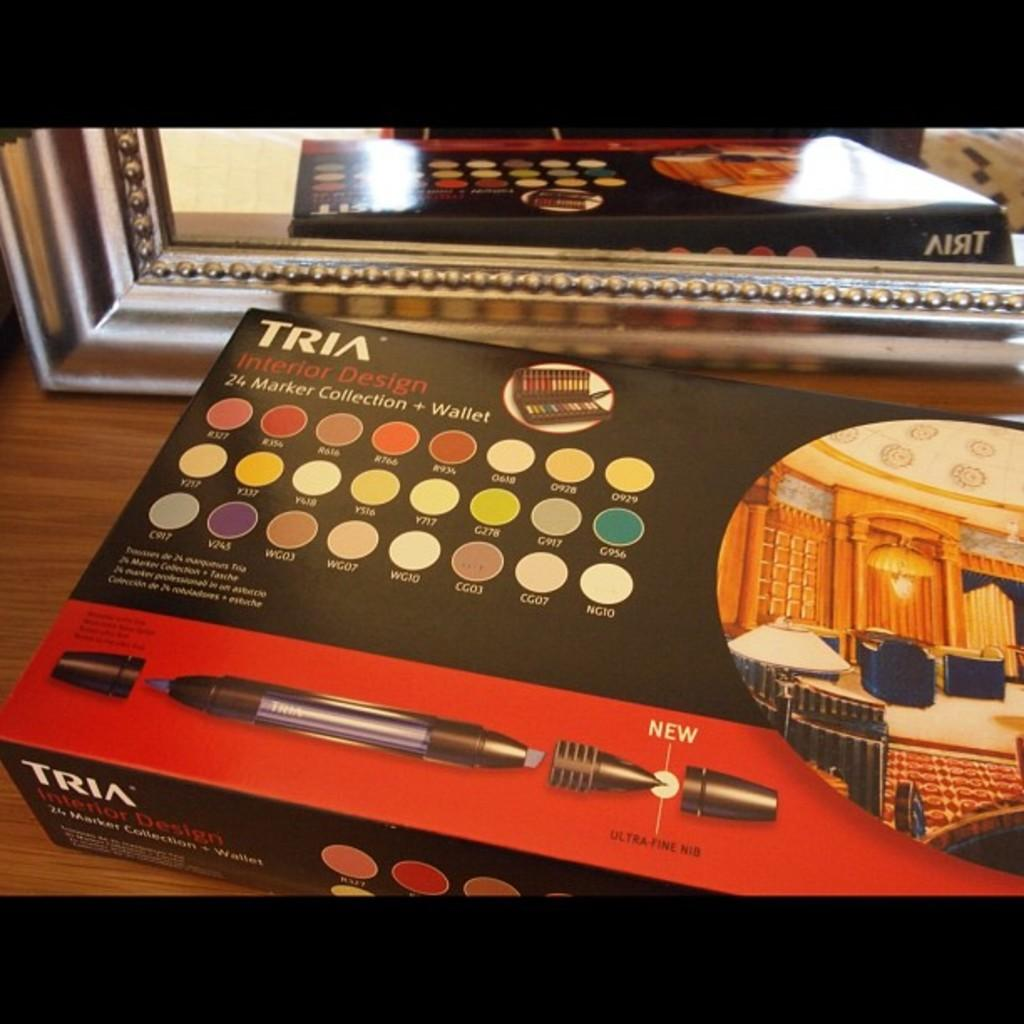<image>
Summarize the visual content of the image. Black and red box of markers that say"Interior Design". 